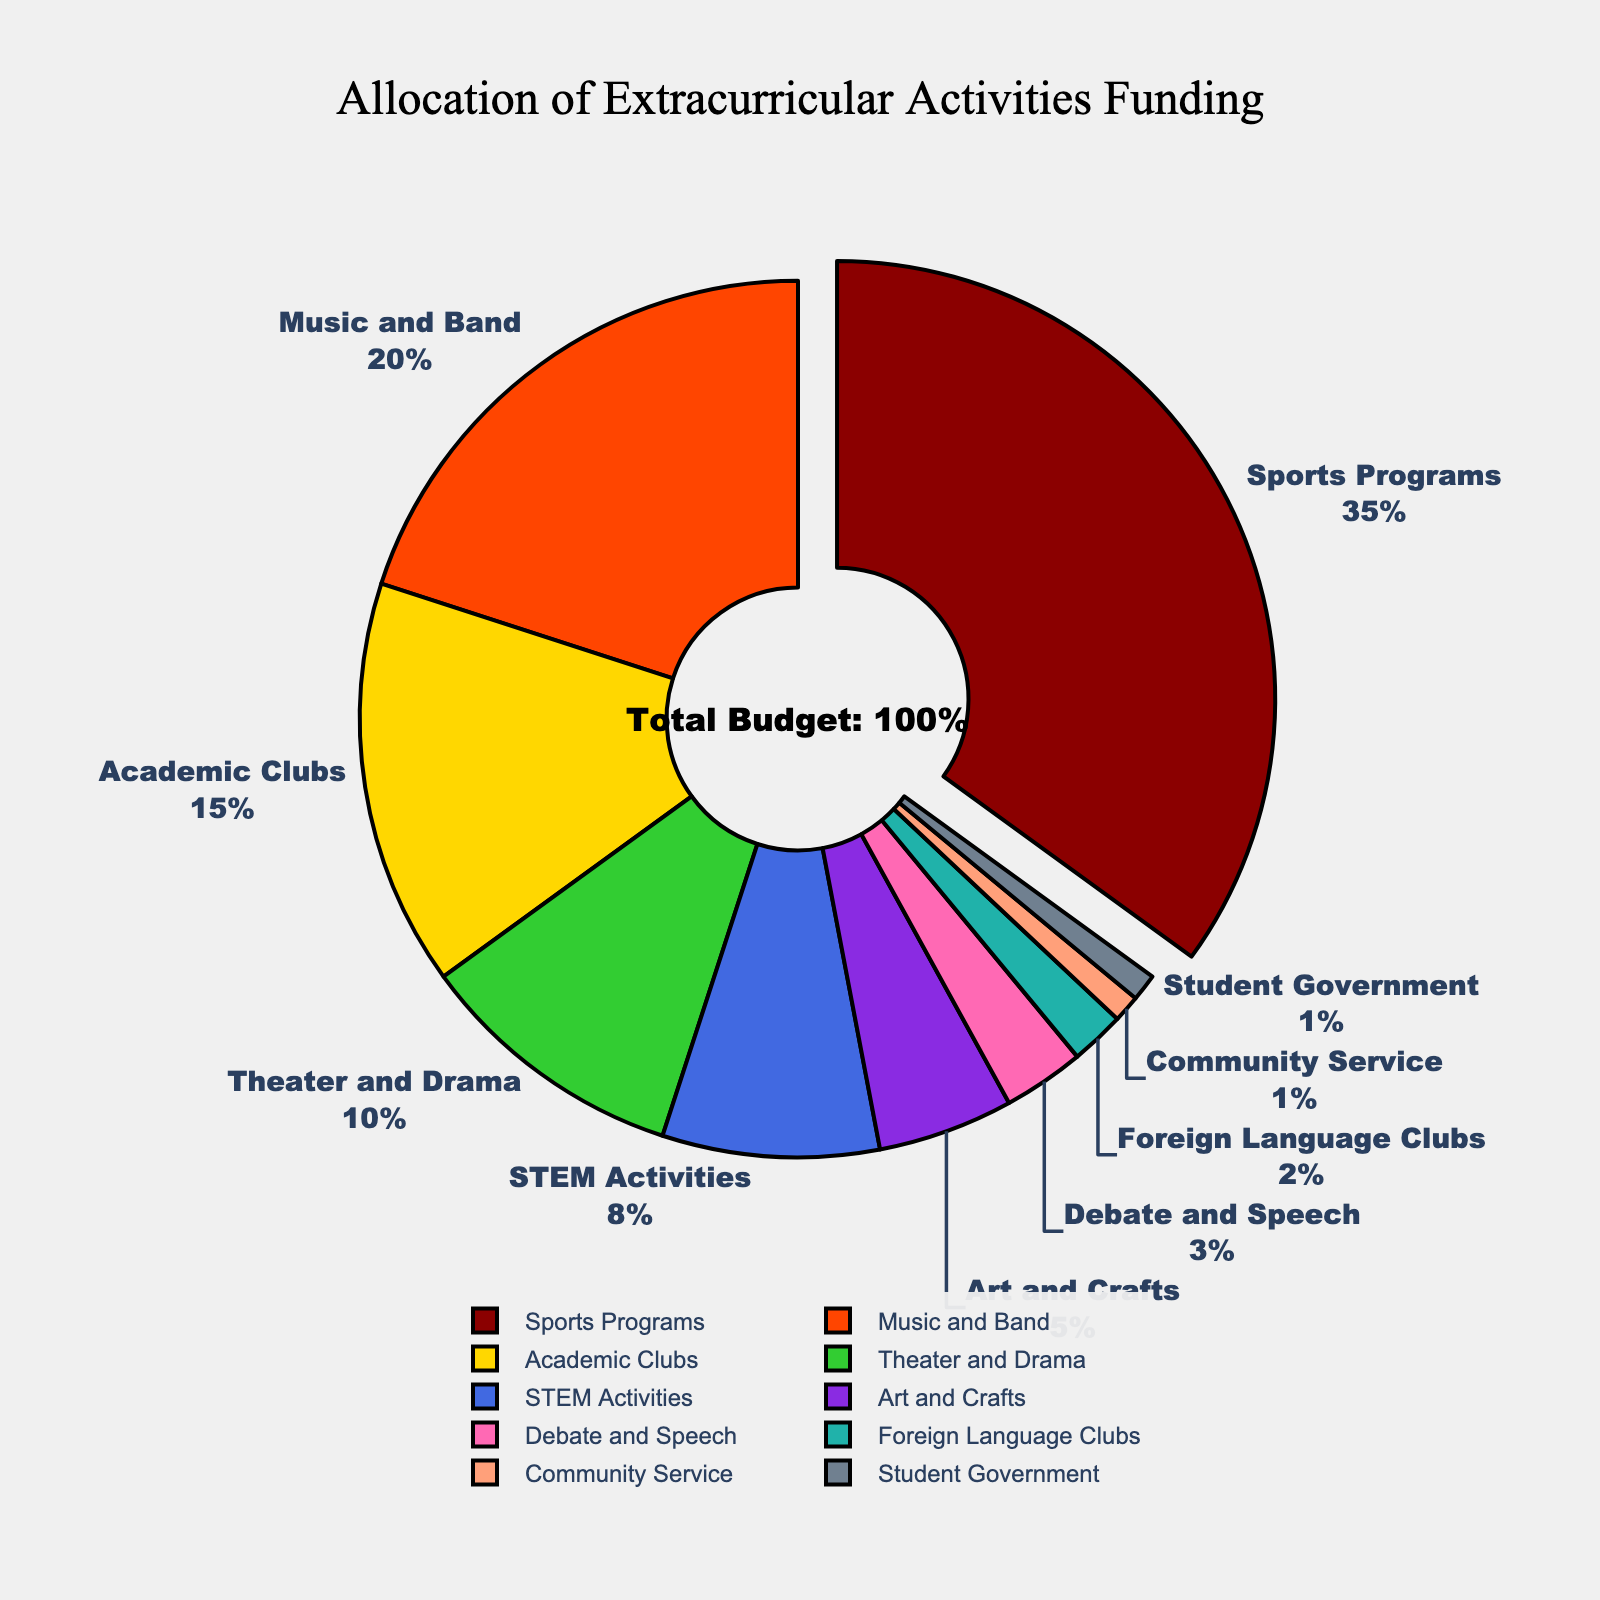What percentage of the funding is allocated to Sports Programs and Music and Band combined? To find out the total percentage allocated to Sports Programs and Music and Band, add the percentages of these two categories. Sports Programs is 35%, and Music and Band is 20%. So, 35 + 20 = 55%.
Answer: 55% Which category receives less funding: Debate and Speech or Foreign Language Clubs? Compare the percentages allocated to Debate and Speech and Foreign Language Clubs. Debate and Speech receives 3%, while Foreign Language Clubs receive 2%. 3% is greater than 2%, so Foreign Language Clubs receive less funding.
Answer: Foreign Language Clubs Which category has the largest percentage of funding and what is that percentage? Identify the category with the largest segment in the pie chart. Sports Programs is the largest, with 35%.
Answer: Sports Programs, 35% What is the total percentage of funding allocated to Academic Clubs, STEM Activities, and Art and Crafts? Add the percentages allocated to Academic Clubs, STEM Activities, and Art and Crafts to find the total. Academic Clubs (15%) + STEM Activities (8%) + Art and Crafts (5%) = 15 + 8 + 5 = 28%.
Answer: 28% How much more funding does Theater and Drama receive compared to Community Service? Subtract the percentage of Community Service from the percentage of Theater and Drama. Theater and Drama receives 10%, whereas Community Service receives 1%. So, 10% - 1% = 9%.
Answer: 9% Which categories are allocated a combined total of 4%? Examine the pie chart for any segments that sum up to 4%. Foreign Language Clubs (2%), Community Service (1%), and Student Government (1%) together make 2 + 1 + 1 = 4%.
Answer: Foreign Language Clubs, Community Service, and Student Government What percentage of funding is allocated to categories other than Sports Programs and Music and Band? Subtract the combined percentage of Sports Programs and Music and Band from 100%. Sports Programs and Music and Band combined are 35% + 20% = 55%. So, 100% - 55% = 45%.
Answer: 45% Out of Theater and Drama, STEM Activities, and Debate and Speech, which receives the highest funding? Compare the percentages represented by Theater and Drama, STEM Activities, and Debate and Speech. Theater and Drama has 10%, STEM Activities has 8%, and Debate and Speech has 3%. Theater and Drama has the highest percentage.
Answer: Theater and Drama 